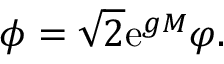Convert formula to latex. <formula><loc_0><loc_0><loc_500><loc_500>\phi = \sqrt { 2 } e ^ { g M } \varphi .</formula> 